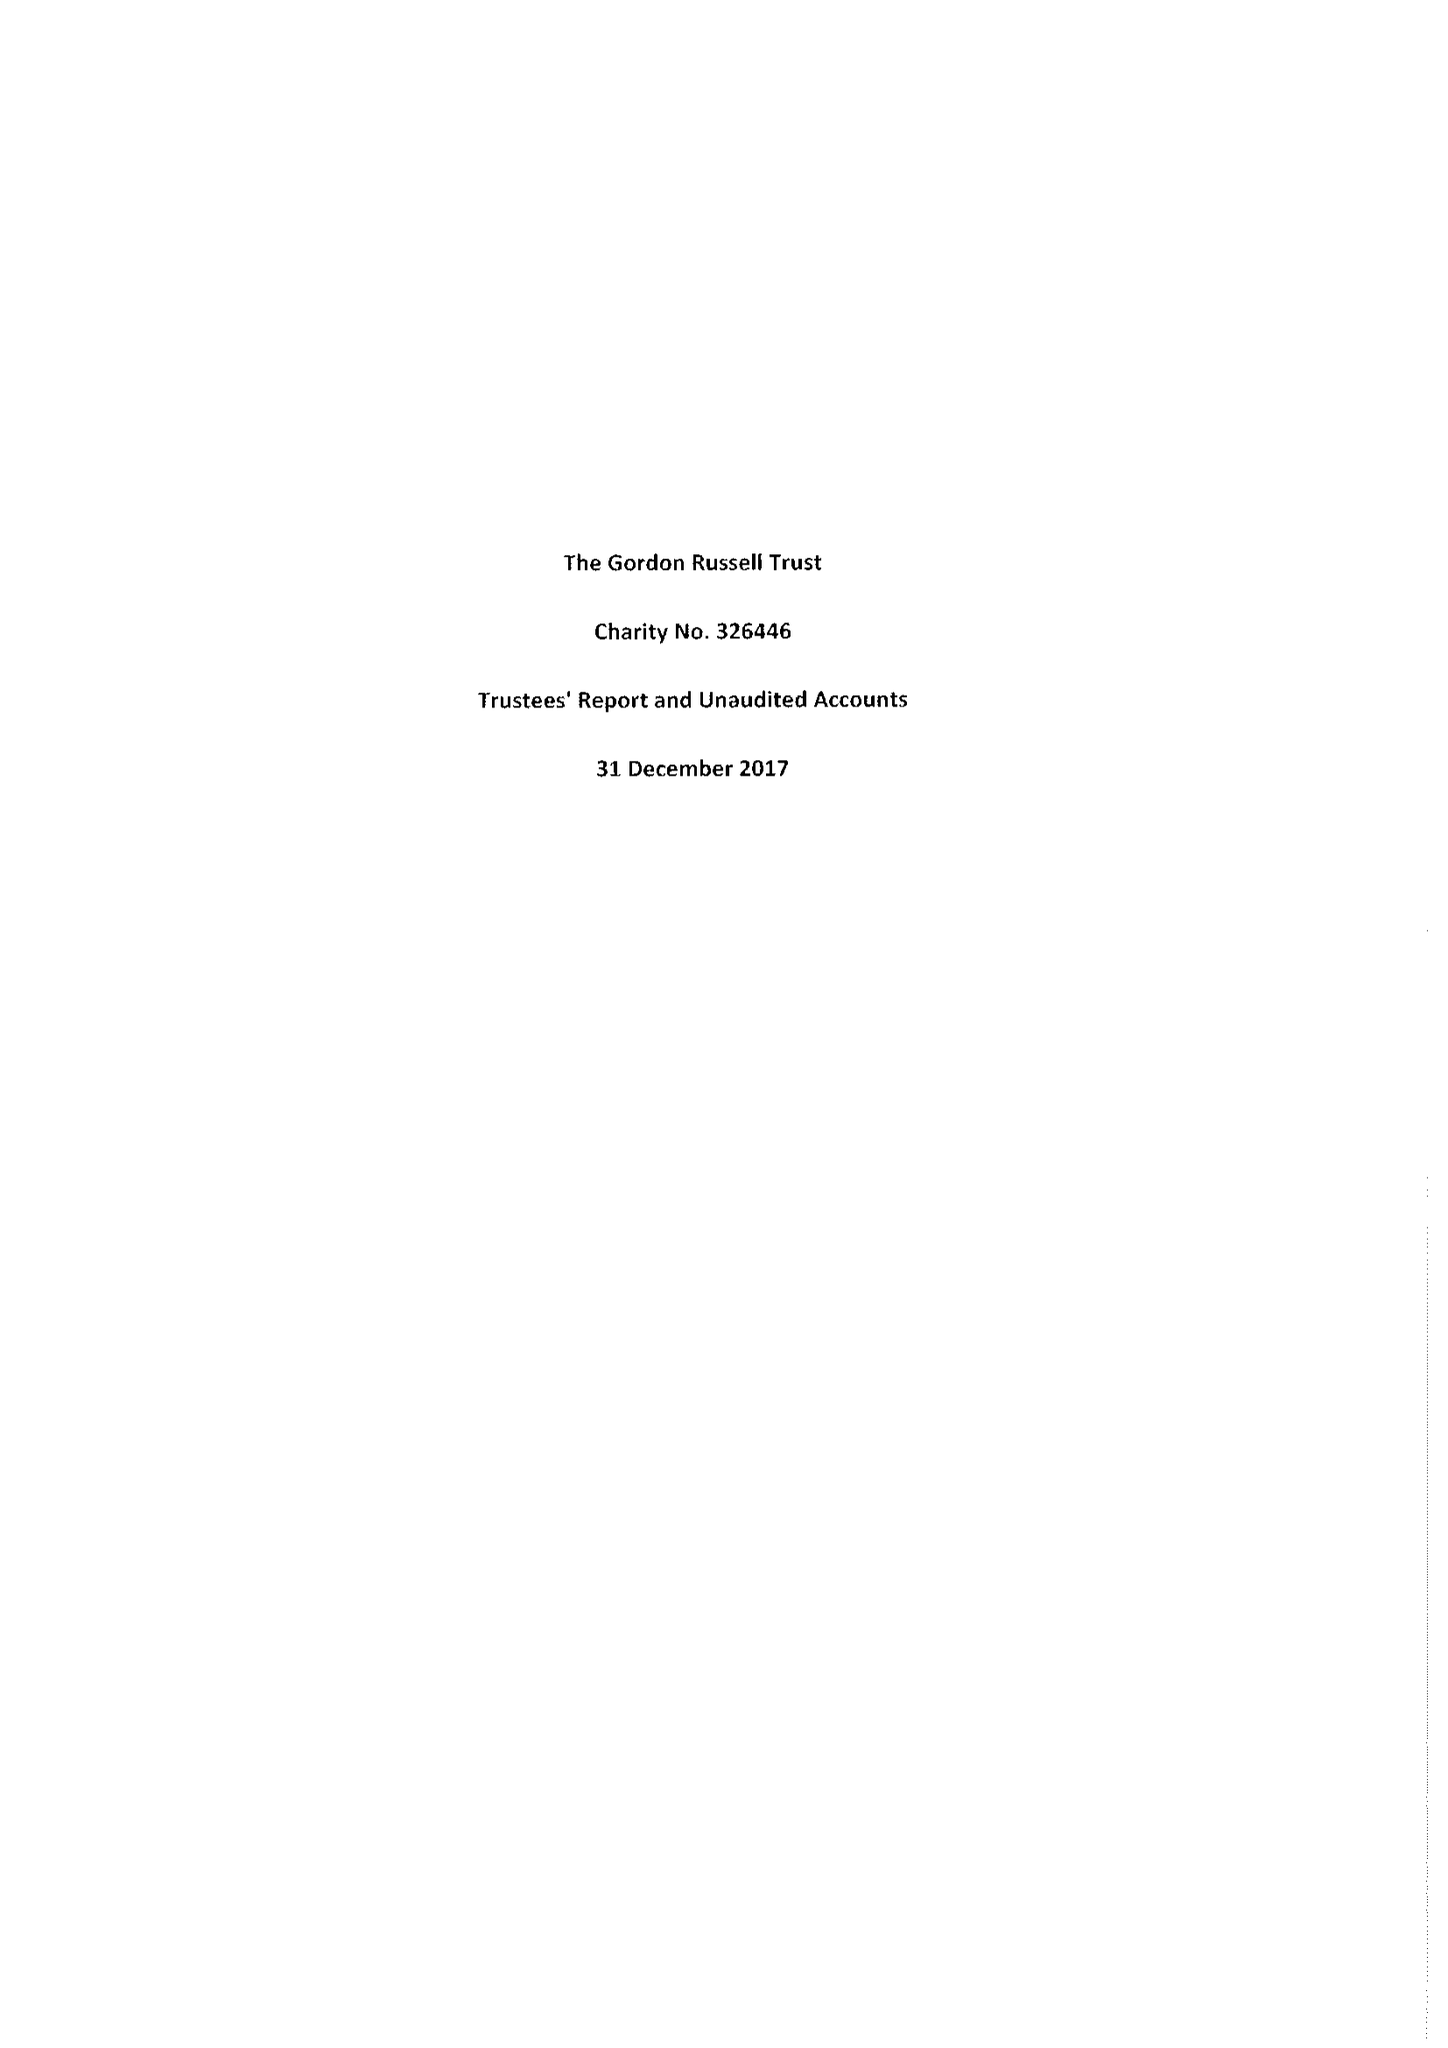What is the value for the charity_name?
Answer the question using a single word or phrase. The Gordon Russell Trust 